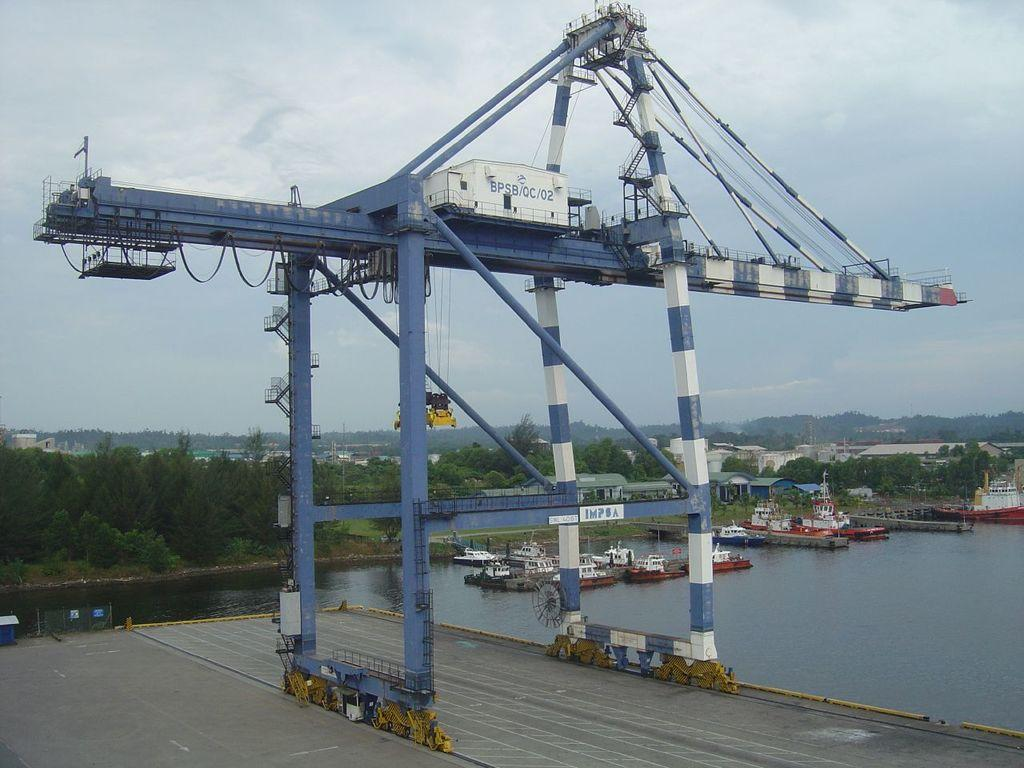What is the main subject of the image? The main subject of the image is a crane with poles and wires. What is attached to the crane? There are objects attached to the crane. What can be seen in the background of the image? There is a road, water with boats, ground with trees, buildings, and the sky with clouds visible in the image. What type of songs can be heard coming from the ants in the image? There are no ants present in the image, and therefore no songs can be heard from them. 